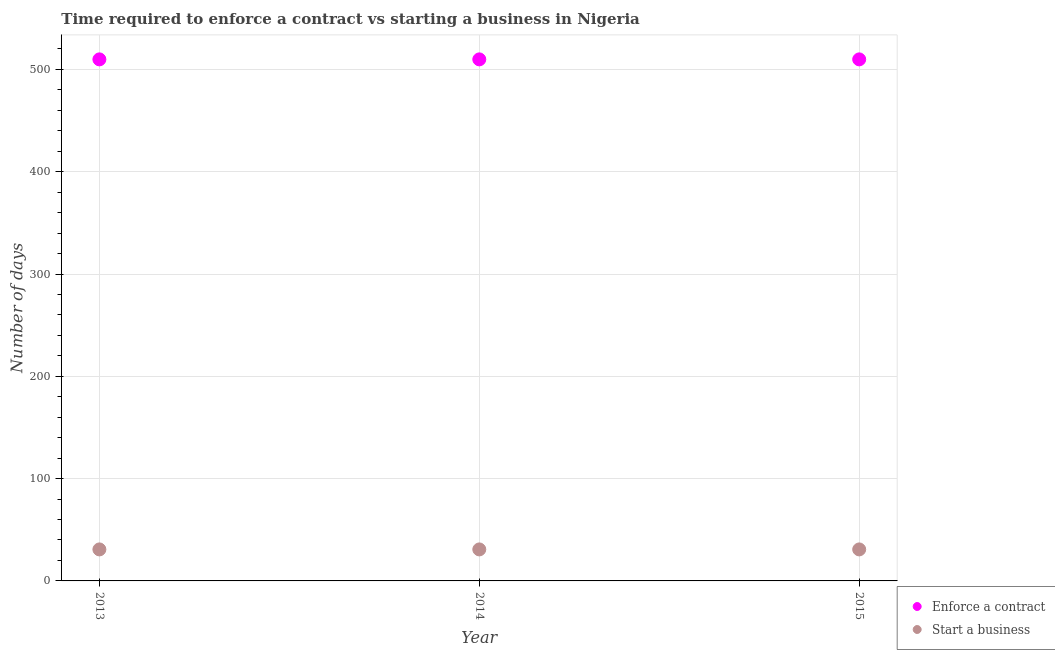How many different coloured dotlines are there?
Keep it short and to the point. 2. Is the number of dotlines equal to the number of legend labels?
Offer a terse response. Yes. What is the number of days to enforece a contract in 2015?
Your response must be concise. 509.8. Across all years, what is the maximum number of days to enforece a contract?
Make the answer very short. 509.8. Across all years, what is the minimum number of days to enforece a contract?
Make the answer very short. 509.8. In which year was the number of days to enforece a contract maximum?
Your answer should be very brief. 2013. In which year was the number of days to start a business minimum?
Your response must be concise. 2013. What is the total number of days to start a business in the graph?
Provide a short and direct response. 92.4. What is the difference between the number of days to enforece a contract in 2013 and that in 2015?
Provide a short and direct response. 0. What is the difference between the number of days to start a business in 2014 and the number of days to enforece a contract in 2013?
Your answer should be compact. -479. What is the average number of days to start a business per year?
Provide a succinct answer. 30.8. In the year 2013, what is the difference between the number of days to enforece a contract and number of days to start a business?
Your response must be concise. 479. In how many years, is the number of days to enforece a contract greater than 180 days?
Your answer should be very brief. 3. What is the ratio of the number of days to enforece a contract in 2013 to that in 2014?
Provide a succinct answer. 1. Is the number of days to enforece a contract in 2013 less than that in 2014?
Provide a succinct answer. No. Is the difference between the number of days to start a business in 2013 and 2015 greater than the difference between the number of days to enforece a contract in 2013 and 2015?
Offer a terse response. No. What is the difference between the highest and the second highest number of days to enforece a contract?
Give a very brief answer. 0. What is the difference between the highest and the lowest number of days to enforece a contract?
Your response must be concise. 0. Is the number of days to enforece a contract strictly greater than the number of days to start a business over the years?
Your answer should be very brief. Yes. Is the number of days to start a business strictly less than the number of days to enforece a contract over the years?
Your response must be concise. Yes. How many dotlines are there?
Your response must be concise. 2. What is the difference between two consecutive major ticks on the Y-axis?
Offer a terse response. 100. Does the graph contain any zero values?
Offer a terse response. No. How many legend labels are there?
Your answer should be very brief. 2. How are the legend labels stacked?
Provide a short and direct response. Vertical. What is the title of the graph?
Provide a short and direct response. Time required to enforce a contract vs starting a business in Nigeria. Does "International Visitors" appear as one of the legend labels in the graph?
Keep it short and to the point. No. What is the label or title of the Y-axis?
Make the answer very short. Number of days. What is the Number of days of Enforce a contract in 2013?
Your response must be concise. 509.8. What is the Number of days of Start a business in 2013?
Give a very brief answer. 30.8. What is the Number of days in Enforce a contract in 2014?
Offer a very short reply. 509.8. What is the Number of days in Start a business in 2014?
Provide a short and direct response. 30.8. What is the Number of days in Enforce a contract in 2015?
Your response must be concise. 509.8. What is the Number of days in Start a business in 2015?
Provide a short and direct response. 30.8. Across all years, what is the maximum Number of days of Enforce a contract?
Provide a succinct answer. 509.8. Across all years, what is the maximum Number of days in Start a business?
Ensure brevity in your answer.  30.8. Across all years, what is the minimum Number of days in Enforce a contract?
Make the answer very short. 509.8. Across all years, what is the minimum Number of days of Start a business?
Your answer should be compact. 30.8. What is the total Number of days of Enforce a contract in the graph?
Provide a short and direct response. 1529.4. What is the total Number of days in Start a business in the graph?
Your answer should be very brief. 92.4. What is the difference between the Number of days of Enforce a contract in 2013 and that in 2014?
Keep it short and to the point. 0. What is the difference between the Number of days of Start a business in 2013 and that in 2014?
Offer a very short reply. 0. What is the difference between the Number of days of Enforce a contract in 2014 and that in 2015?
Provide a short and direct response. 0. What is the difference between the Number of days of Start a business in 2014 and that in 2015?
Your response must be concise. 0. What is the difference between the Number of days of Enforce a contract in 2013 and the Number of days of Start a business in 2014?
Your answer should be compact. 479. What is the difference between the Number of days in Enforce a contract in 2013 and the Number of days in Start a business in 2015?
Your answer should be compact. 479. What is the difference between the Number of days of Enforce a contract in 2014 and the Number of days of Start a business in 2015?
Keep it short and to the point. 479. What is the average Number of days of Enforce a contract per year?
Give a very brief answer. 509.8. What is the average Number of days in Start a business per year?
Make the answer very short. 30.8. In the year 2013, what is the difference between the Number of days in Enforce a contract and Number of days in Start a business?
Offer a very short reply. 479. In the year 2014, what is the difference between the Number of days in Enforce a contract and Number of days in Start a business?
Provide a short and direct response. 479. In the year 2015, what is the difference between the Number of days in Enforce a contract and Number of days in Start a business?
Your answer should be compact. 479. What is the ratio of the Number of days in Enforce a contract in 2013 to that in 2014?
Provide a short and direct response. 1. What is the ratio of the Number of days of Start a business in 2013 to that in 2015?
Keep it short and to the point. 1. What is the difference between the highest and the second highest Number of days in Start a business?
Provide a short and direct response. 0. 